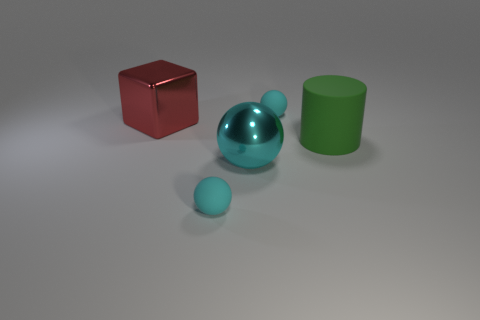Subtract all small matte spheres. How many spheres are left? 1 Add 4 big green rubber cylinders. How many objects exist? 9 Subtract all blocks. How many objects are left? 4 Subtract 3 spheres. How many spheres are left? 0 Subtract all brown cubes. Subtract all green cylinders. How many cubes are left? 1 Subtract all large purple rubber balls. Subtract all tiny cyan spheres. How many objects are left? 3 Add 1 rubber objects. How many rubber objects are left? 4 Add 5 cyan shiny spheres. How many cyan shiny spheres exist? 6 Subtract 1 green cylinders. How many objects are left? 4 